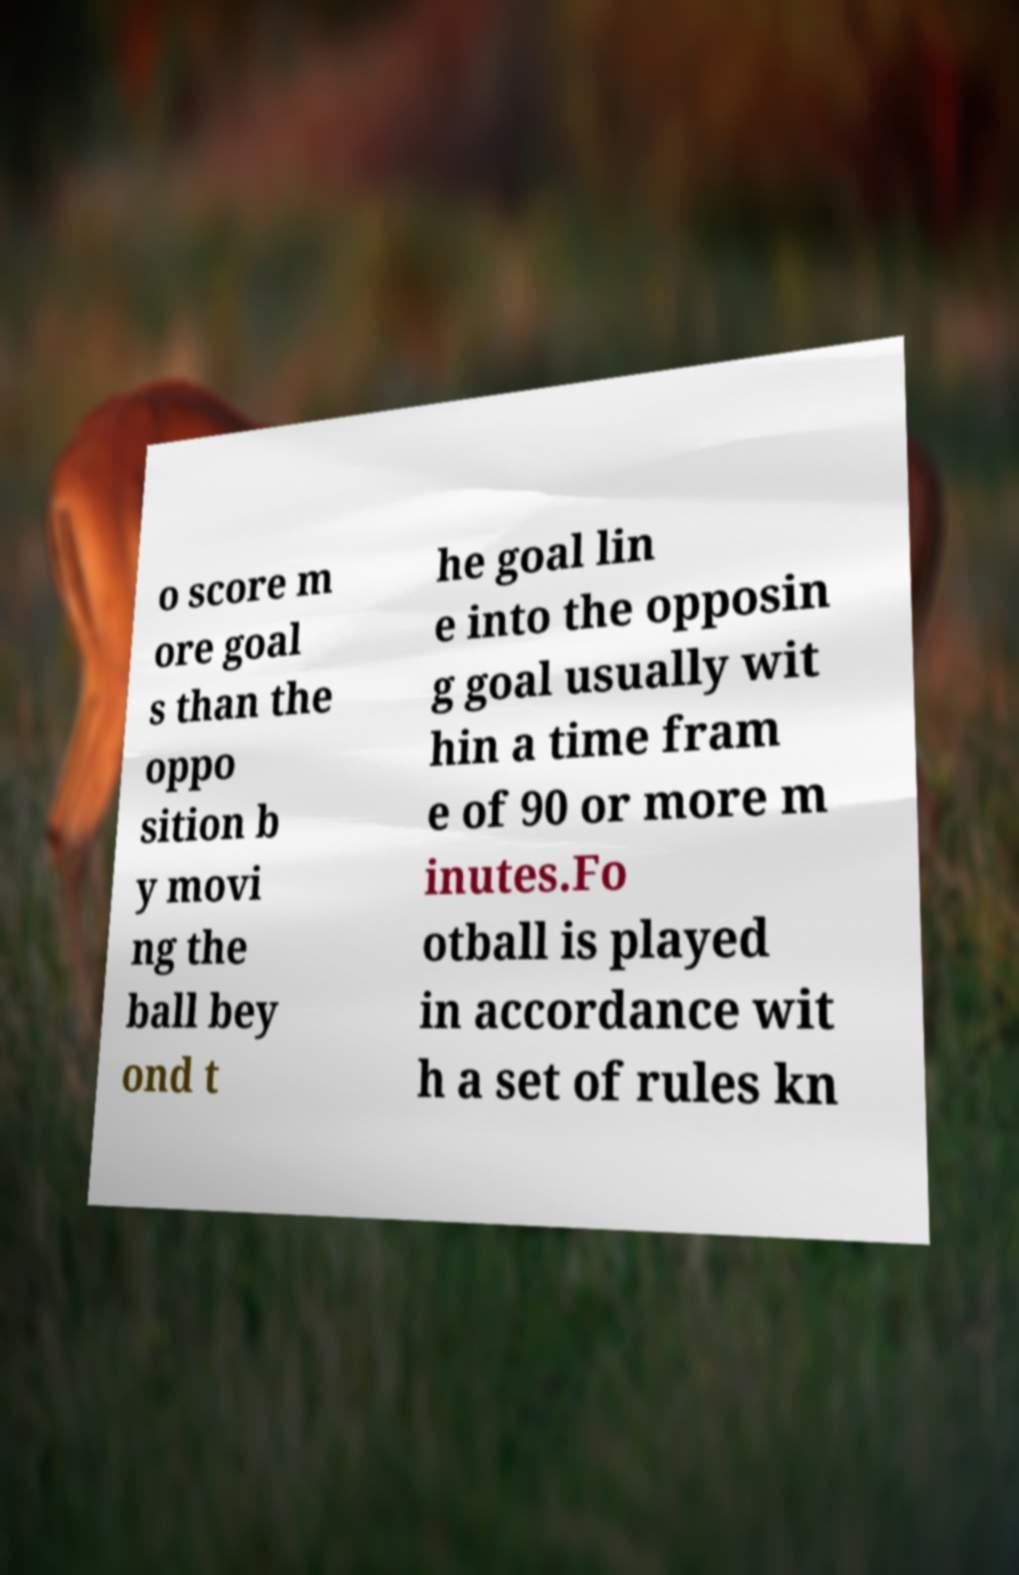What messages or text are displayed in this image? I need them in a readable, typed format. o score m ore goal s than the oppo sition b y movi ng the ball bey ond t he goal lin e into the opposin g goal usually wit hin a time fram e of 90 or more m inutes.Fo otball is played in accordance wit h a set of rules kn 